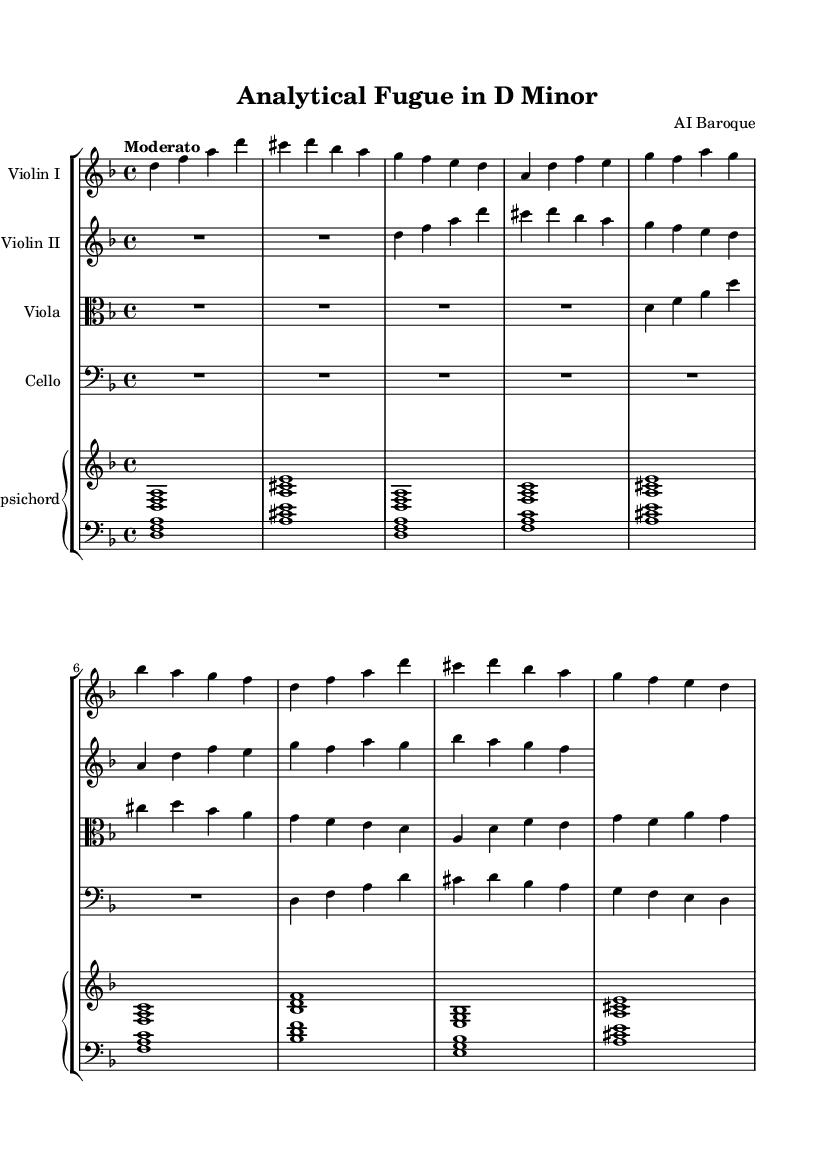What is the key signature of this music? The key signature is indicated at the beginning of the staff, showing two flats (B♭ and E♭).
Answer: D minor What is the time signature of the piece? The time signature is found at the beginning of the score and shows a "4/4", which means four beats per measure.
Answer: 4/4 What is the tempo marking of the piece? The tempo is indicated above the staff, stating "Moderato", which guides the speed at which the piece should be played.
Answer: Moderato How many measures are in the score? By counting the number of vertical lines (bar lines) that separate the measures in the score, you can determine the total. There are eight measures in each staff.
Answer: 8 What instruments are included in this chamber music? The instruments are explicitly listed at the start of each staff in the score, which includes two violins, a viola, a cello, and a harpsichord.
Answer: Violin I, Violin II, Viola, Cello, Harpsichord What is the role of the harpsichord in this piece? The harpsichord provides a harmonic foundation and accompaniment, as typically seen in Baroque chamber music, and its part is written in a separate staff labeled "Harpsichord".
Answer: Harmonic foundation What form does this piece exhibit, typical of Baroque music? The structure of the musical content, characterized by the repetition and variation of themes, suggests a fugue form, which is common in Baroque compositions.
Answer: Fugue 